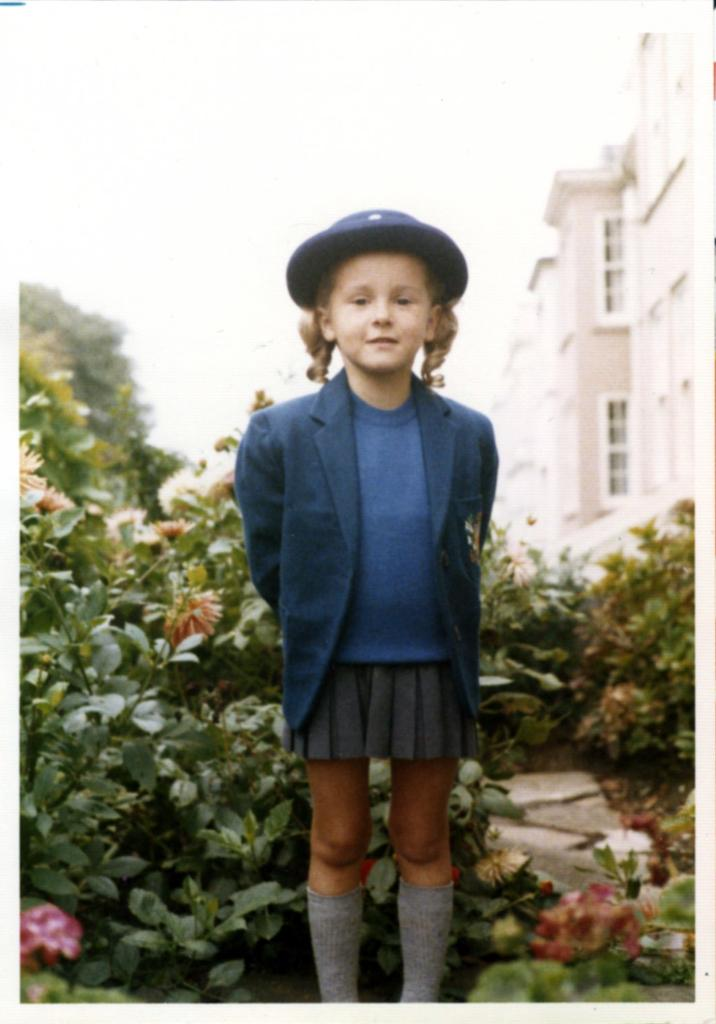Who is the main subject in the image? There is a girl in the image. What is the girl doing in the image? The girl is standing. What is the girl wearing on her head? The girl is wearing a hat. What color is the girl's coat? The girl is wearing a black color coat. What type of clothing is the girl wearing on her lower body? The girl is wearing a skirt. What can be seen in the background of the image? There are plants, the sky, and buildings visible in the background of the image. What type of knowledge can be gained from the shock of the mass in the image? There is no shock or mass present in the image, so it is not possible to gain knowledge from them. 